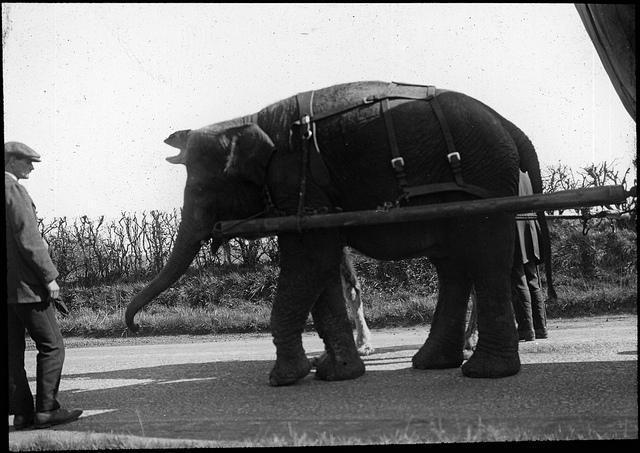How many  legs does the animal have?
Give a very brief answer. 4. How many people are in the picture?
Give a very brief answer. 2. How many dogs are wearing a chain collar?
Give a very brief answer. 0. 